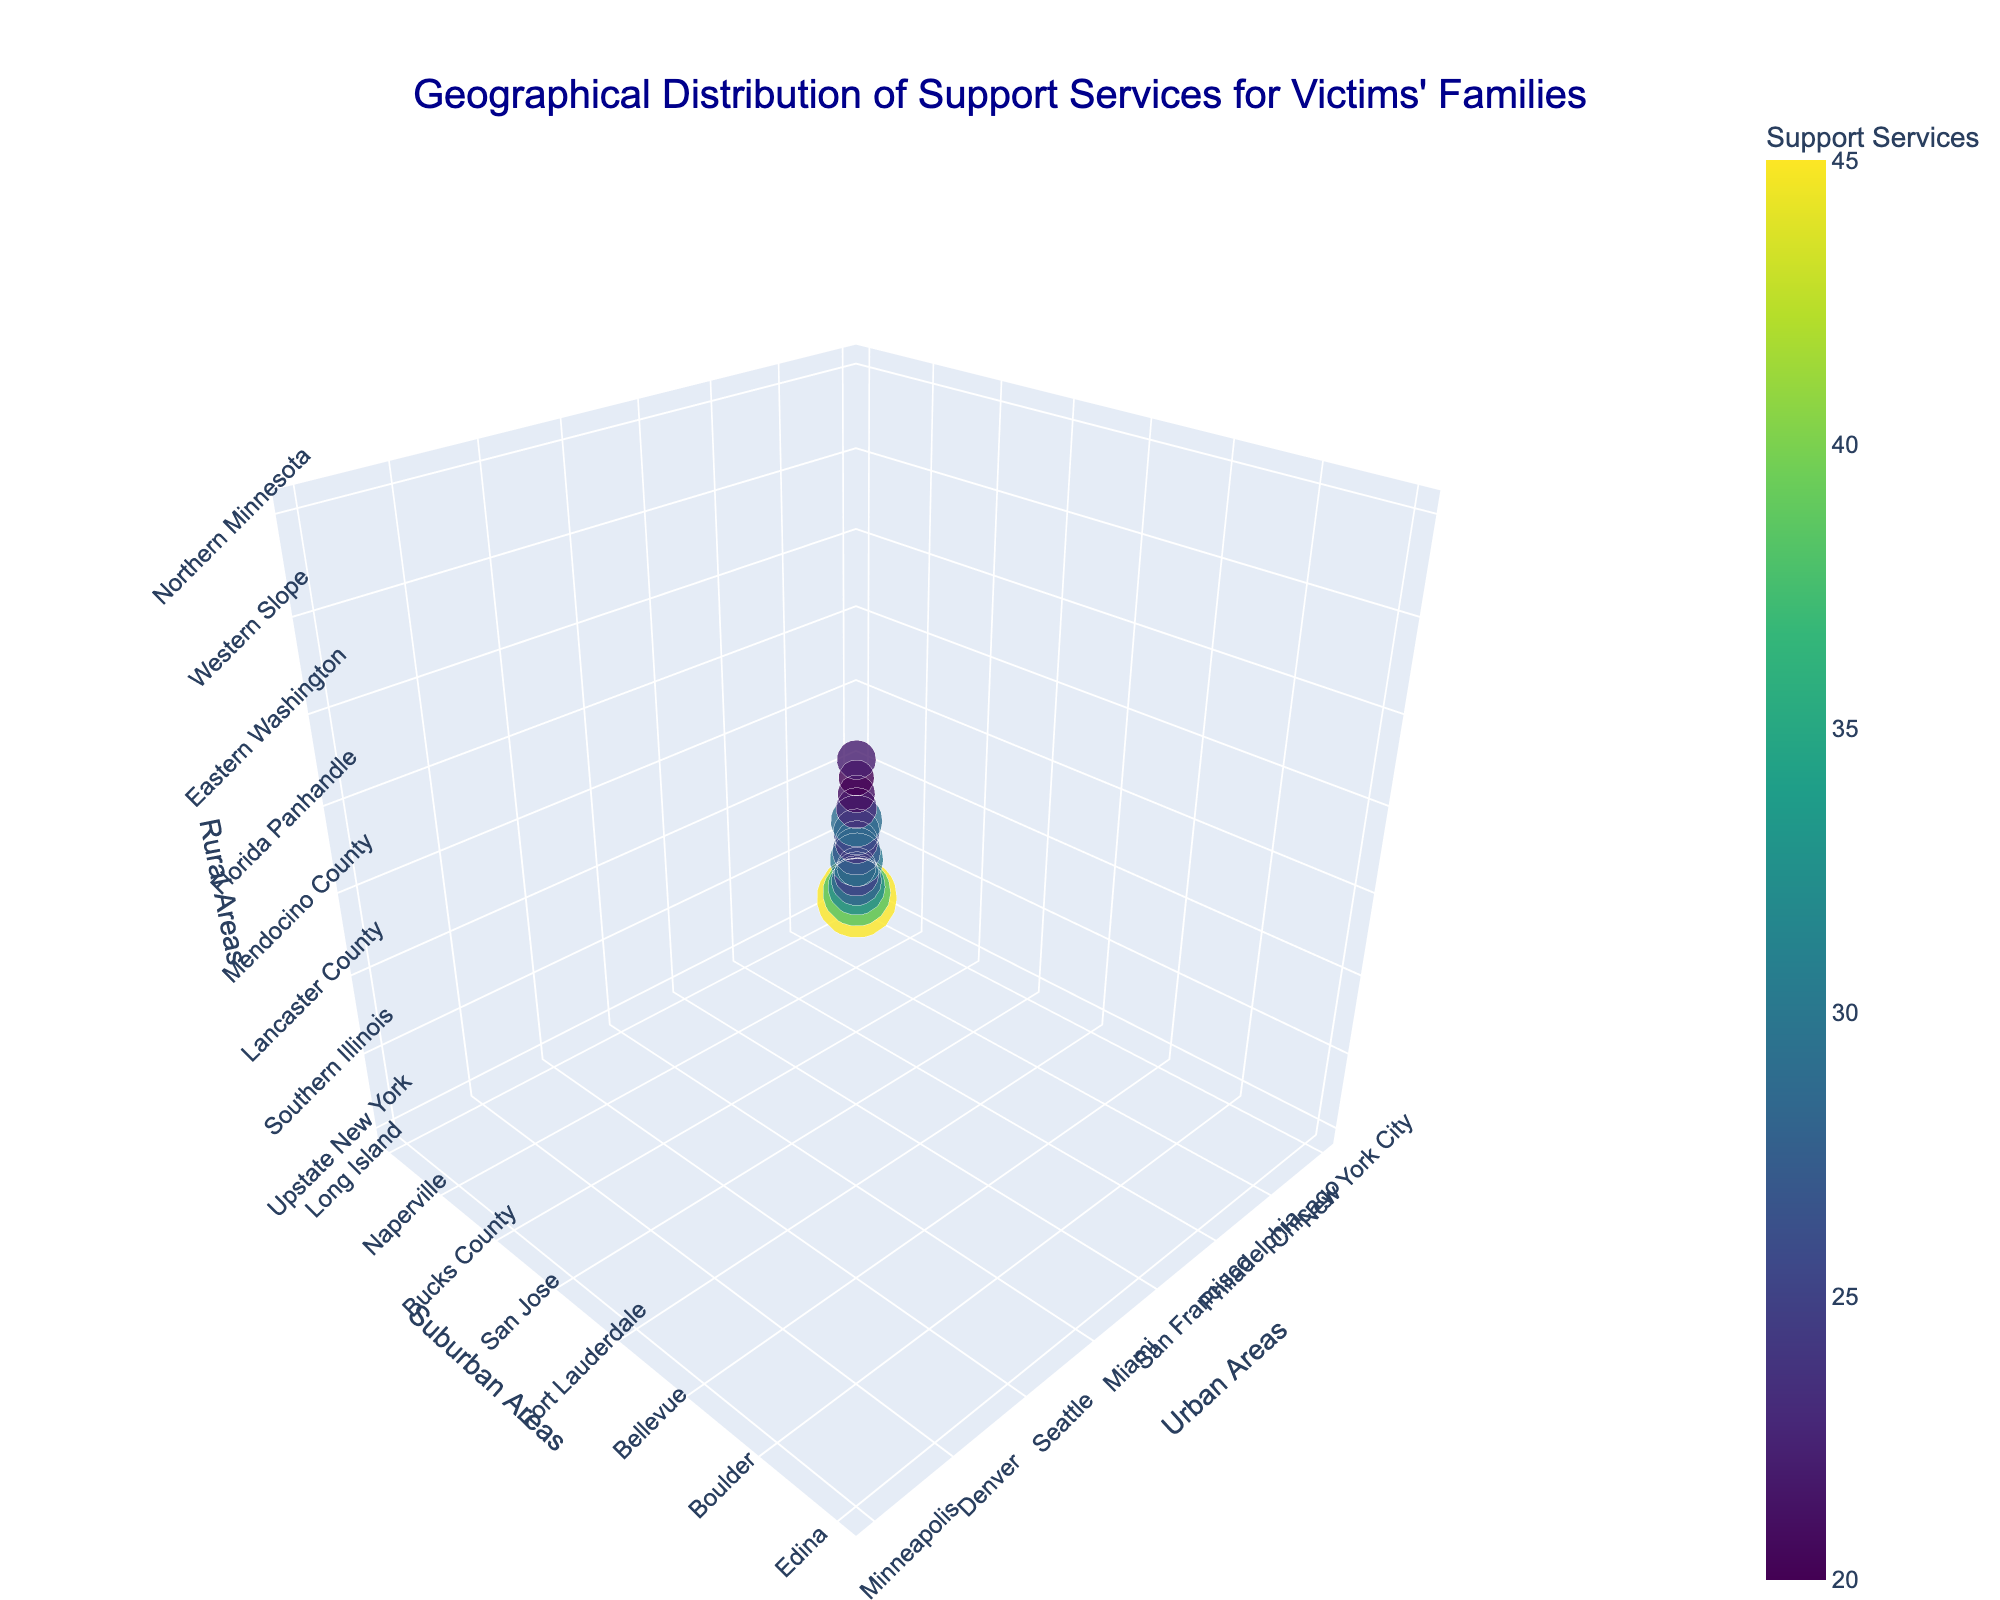What does the marker size in the figure represent? The marker size in the figure is proportional to the amount of support services provided in each geographic area. This information is seen by identifying the legend or hover text for the data points.
Answer: Support services How many data points are in the figure? To determine the number of data points displayed, we can refer to the number of markers. Each location represents one data point. Counting all the visual markers in the figure gives us the total number of data points.
Answer: 15 Which urban area has the largest amount of support services? By checking the markers' size or the color gradient (darkest color) and the hover text, we can identify which urban area corresponds to the largest value for support services. For example, New York City has the largest support services value as indicated by the largest and darkest marker.
Answer: New York City What are the names of the suburban areas with the smallest support services? Identify the smallest markers in the plot and refer to their hover text. For suburban areas, the area with the numerically smallest support services value (20) is Ann Arbor.
Answer: Ann Arbor Can you compare the support services between urban areas of Chicago and Boston? Look at the markers representing Chicago and Boston, and refer to their hover text or marker sizes to compare the support services. Chicago has a value of 32 and Boston has a value of 27.
Answer: Chicago has more Which rural area corresponds to the highest support services value? By checking the rural column's alignment with the largest marker or the marker with the darkest color on the plot, you can identify the corresponding rural area. Upstate New York is associated with the highest support services value.
Answer: Upstate New York What is the average amount of support services among all the urban areas? Sum the values of support services for all urban areas and divide by the number of data points (15). The total is 420, dividing by 15 yields 28.
Answer: 28 Which areas have a support service value of 25? Observe the markers and their hover text for any value showing 25. Philadelphia’s triad including Bucks County and Lancaster County shows a marker with this value.
Answer: Philadelphia What is the color scheme used for the marker colors and what does it signify? The color scheme used is Viridis, a color gradient that ranges from lighter to darker shades. The color indicates the value of support services, with lighter colors denoting lower values and darker colors representing higher values.
Answer: Viridis, signifies support services Among Seattle, Bellevue, and Eastern Washington, which area shows a mid-level support service and what is its value? By comparing the hover text or marker size for these areas, Bellevue in suburban shows a mid-level support services value compared to Seattle and Eastern Washington. Its value is 29.
Answer: Bellevue, 29 